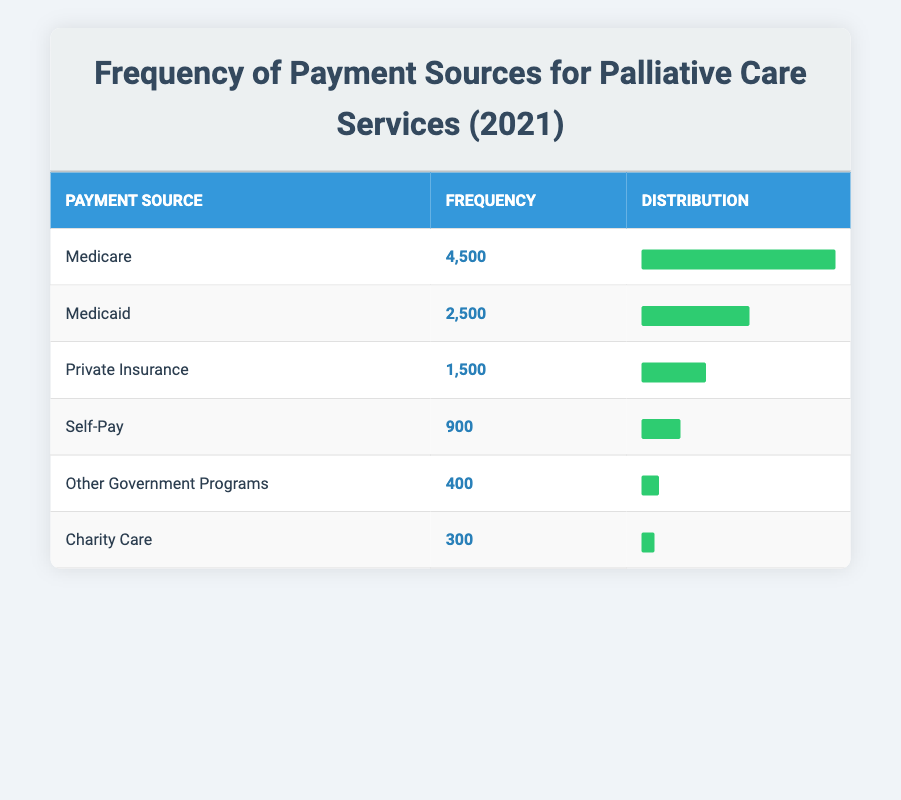What is the frequency of payments from Medicare for palliative care services in 2021? The table shows that the frequency of payments from Medicare is listed directly under the "Frequency" column for Medicare. According to the table, it states "4,500" for Medicare.
Answer: 4500 Which payment source has the lowest frequency in 2021? By reviewing the "Frequency" column of the table, we see that "Charity Care" has the frequency of "300," which is lower than all other payment sources listed.
Answer: Charity Care What is the total frequency of payments from Medicaid and Medicare combined? To find the total frequency of payments, we add the values for Medicaid "2,500" and Medicare "4,500." This results in a sum of 2,500 + 4,500 = 7,000.
Answer: 7000 Is the frequency of payment from Private Insurance greater than that of Self-Pay in 2021? Looking at the table, the frequency for Private Insurance is "1,500," and for Self-Pay, it is "900." Comparing these values, 1,500 is greater than 900, so the statement is true.
Answer: Yes What proportion of total payments in 2021 came from Medicare? First, we calculate the total frequency of all payment sources, which is 4,500 (Medicare) + 2,500 (Medicaid) + 1,500 (Private Insurance) + 900 (Self-Pay) + 300 (Charity Care) + 400 (Other Government Programs) = 10,100. Next, we find the proportion from Medicare as 4,500 / 10,100 = 0.445. This translates to approximately 44.5% of total payments.
Answer: 44.5% Which payment source accounts for less than 10% of total payments? By calculating the total frequency as 10,100, we look for sources where their frequency is less than 1,010 (which is 10% of 10,100). Both "Charity Care" (300) and "Other Government Programs" (400) meet this criterion since both are below 1,010.
Answer: Charity Care and Other Government Programs What is the frequency difference between Medicaid and Private Insurance? To find the frequency difference, we subtract the frequency of Private Insurance ("1,500") from the frequency of Medicaid ("2,500"). 2,500 - 1,500 = 1,000.
Answer: 1000 Did the combined frequency of Self-Pay and Charity Care exceed the frequency of Medicaid? First, we sum the frequencies of Self-Pay ("900") and Charity Care ("300") to get a total of 1,200. Next, we compare it to Medicaid's frequency of "2,500." Since 1,200 is less than 2,500, the statement is false.
Answer: No 